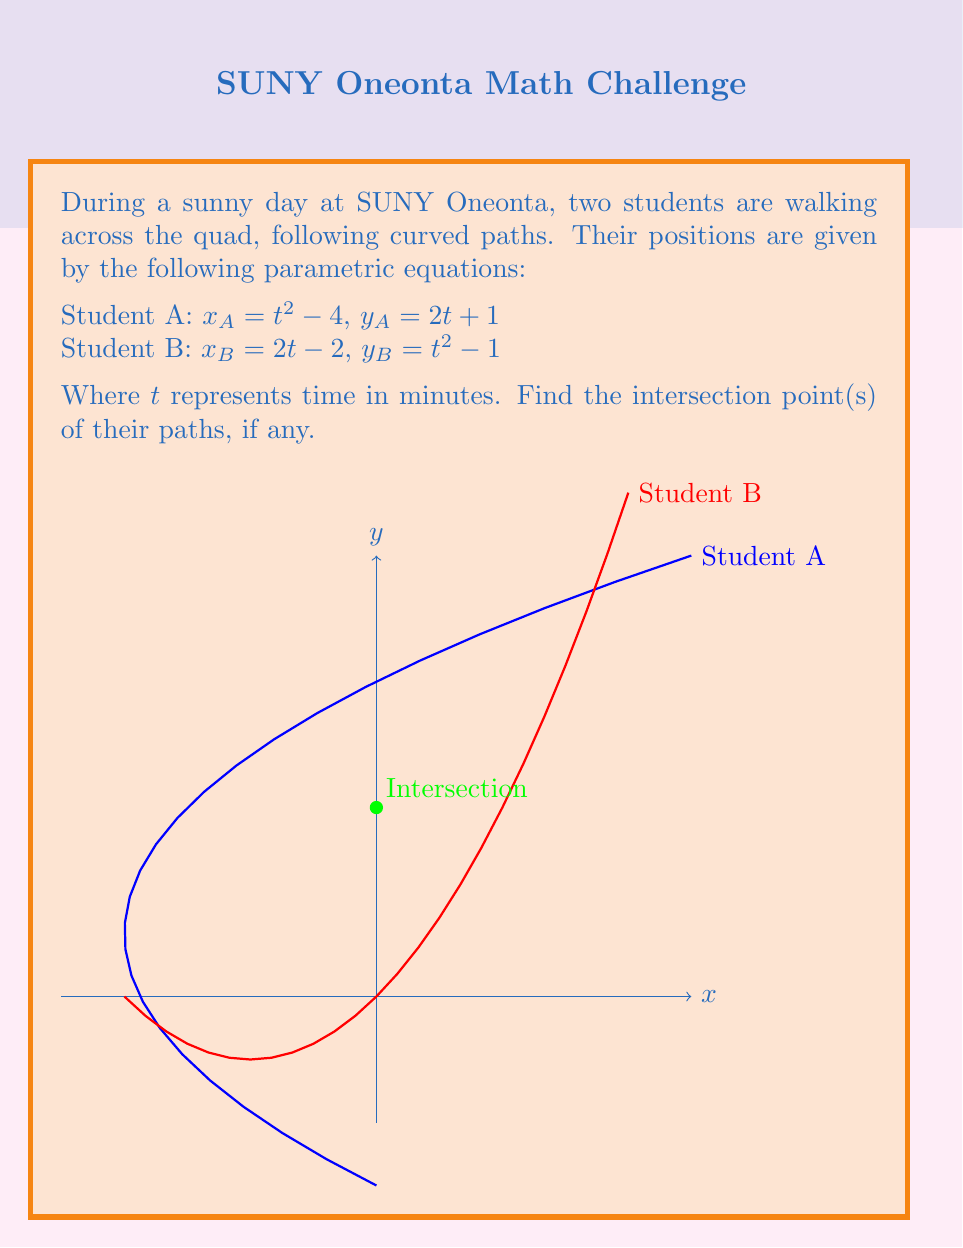Show me your answer to this math problem. Let's solve this step-by-step:

1) For the paths to intersect, both x and y coordinates must be equal at some point. So, we set up the equations:

   $x_A = x_B$ and $y_A = y_B$

2) Substituting the given equations:

   $t^2 - 4 = 2t - 2$ and $2t + 1 = t^2 - 1$

3) Let's solve the second equation first:
   
   $2t + 1 = t^2 - 1$
   $t^2 - 2t - 2 = 0$

4) This is a quadratic equation. We can solve it using the quadratic formula:
   $t = \frac{-b \pm \sqrt{b^2 - 4ac}}{2a}$

   Here, $a=1$, $b=-2$, and $c=-2$

   $t = \frac{2 \pm \sqrt{4 + 8}}{2} = \frac{2 \pm \sqrt{12}}{2} = \frac{2 \pm 2\sqrt{3}}{2}$

   $t = 1 \pm \sqrt{3}$

5) We need to check both solutions in the first equation:

   For $t = 1 + \sqrt{3}$:
   $(1 + \sqrt{3})^2 - 4 = 2(1 + \sqrt{3}) - 2$
   $4 + 2\sqrt{3} - 4 = 2 + 2\sqrt{3} - 2$
   $2\sqrt{3} = 2\sqrt{3}$ (This checks out)

   For $t = 1 - \sqrt{3}$:
   $(1 - \sqrt{3})^2 - 4 = 2(1 - \sqrt{3}) - 2$
   $4 - 2\sqrt{3} - 4 = 2 - 2\sqrt{3} - 2$
   $-2\sqrt{3} = -2\sqrt{3}$ (This also checks out)

6) Now, we need to find the (x,y) coordinates for these t values:

   For $t = 1 + \sqrt{3}$:
   $x = (1 + \sqrt{3})^2 - 4 = 4 + 2\sqrt{3} - 4 = 2\sqrt{3}$
   $y = 2(1 + \sqrt{3}) + 1 = 2 + 2\sqrt{3} + 1 = 3 + 2\sqrt{3}$

   For $t = 1 - \sqrt{3}$:
   $x = (1 - \sqrt{3})^2 - 4 = 4 - 2\sqrt{3} - 4 = -2\sqrt{3}$
   $y = 2(1 - \sqrt{3}) + 1 = 2 - 2\sqrt{3} + 1 = 3 - 2\sqrt{3}$

Therefore, the paths intersect at two points: $(2\sqrt{3}, 3 + 2\sqrt{3})$ and $(-2\sqrt{3}, 3 - 2\sqrt{3})$.
Answer: $(2\sqrt{3}, 3 + 2\sqrt{3})$ and $(-2\sqrt{3}, 3 - 2\sqrt{3})$ 